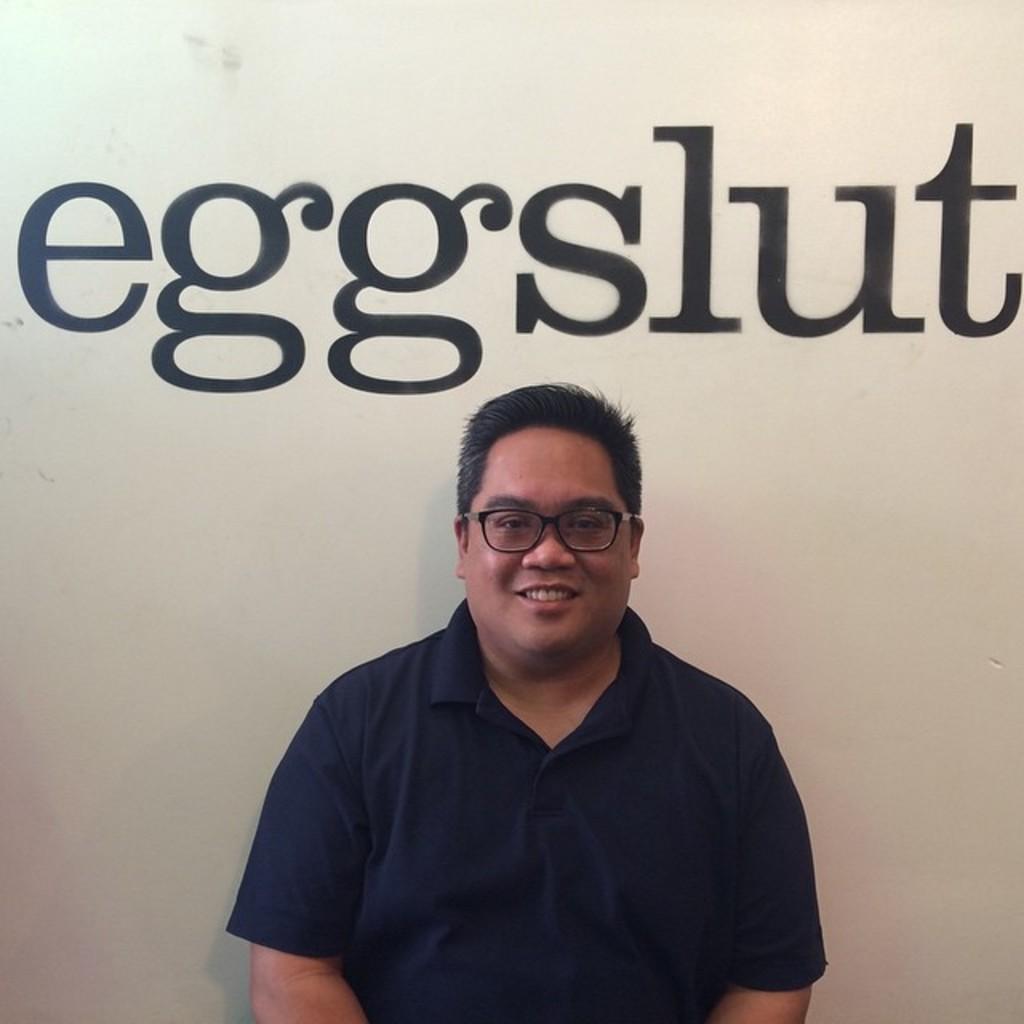In one or two sentences, can you explain what this image depicts? In this image we can see a man sitting and smiling. In the background there is a wall and some text on it. 